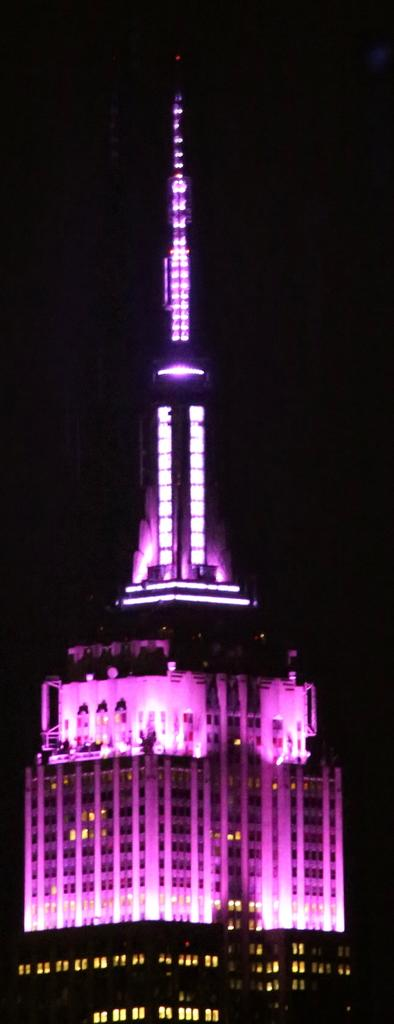What type of structure is in the image? There is a building in the image. What feature can be seen on the building? There is a tower on the building. What colors of light are visible in the image? Yellow and violet color light are visible. How would you describe the background of the image? The background of the image is dark. Can you see a dog playing with a string in the image? There is no dog or string present in the image. What type of connection can be seen between the building and the tower in the image? The image does not show a connection between the building and the tower; it simply depicts a building with a tower on it. 